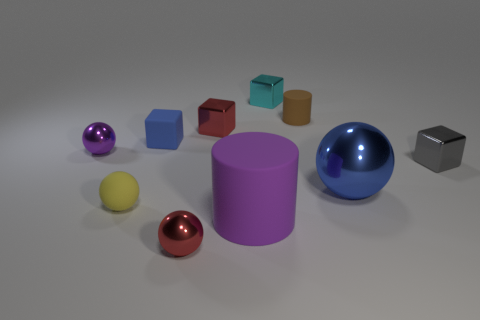Subtract 2 balls. How many balls are left? 2 Subtract all cyan balls. Subtract all blue cubes. How many balls are left? 4 Subtract all cylinders. How many objects are left? 8 Add 5 brown rubber cylinders. How many brown rubber cylinders are left? 6 Add 6 large cyan rubber cubes. How many large cyan rubber cubes exist? 6 Subtract 1 cyan cubes. How many objects are left? 9 Subtract all gray shiny cubes. Subtract all large blue spheres. How many objects are left? 8 